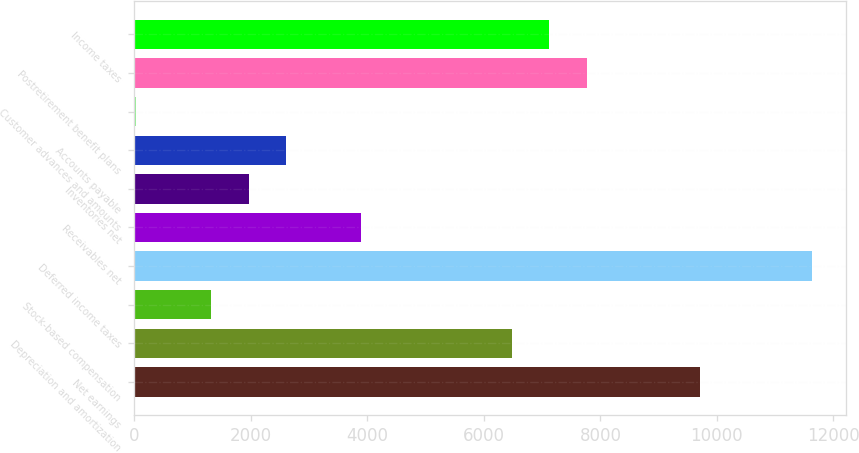Convert chart to OTSL. <chart><loc_0><loc_0><loc_500><loc_500><bar_chart><fcel>Net earnings<fcel>Depreciation and amortization<fcel>Stock-based compensation<fcel>Deferred income taxes<fcel>Receivables net<fcel>Inventories net<fcel>Accounts payable<fcel>Customer advances and amounts<fcel>Postretirement benefit plans<fcel>Income taxes<nl><fcel>9702<fcel>6476<fcel>1314.4<fcel>11637.6<fcel>3895.2<fcel>1959.6<fcel>2604.8<fcel>24<fcel>7766.4<fcel>7121.2<nl></chart> 